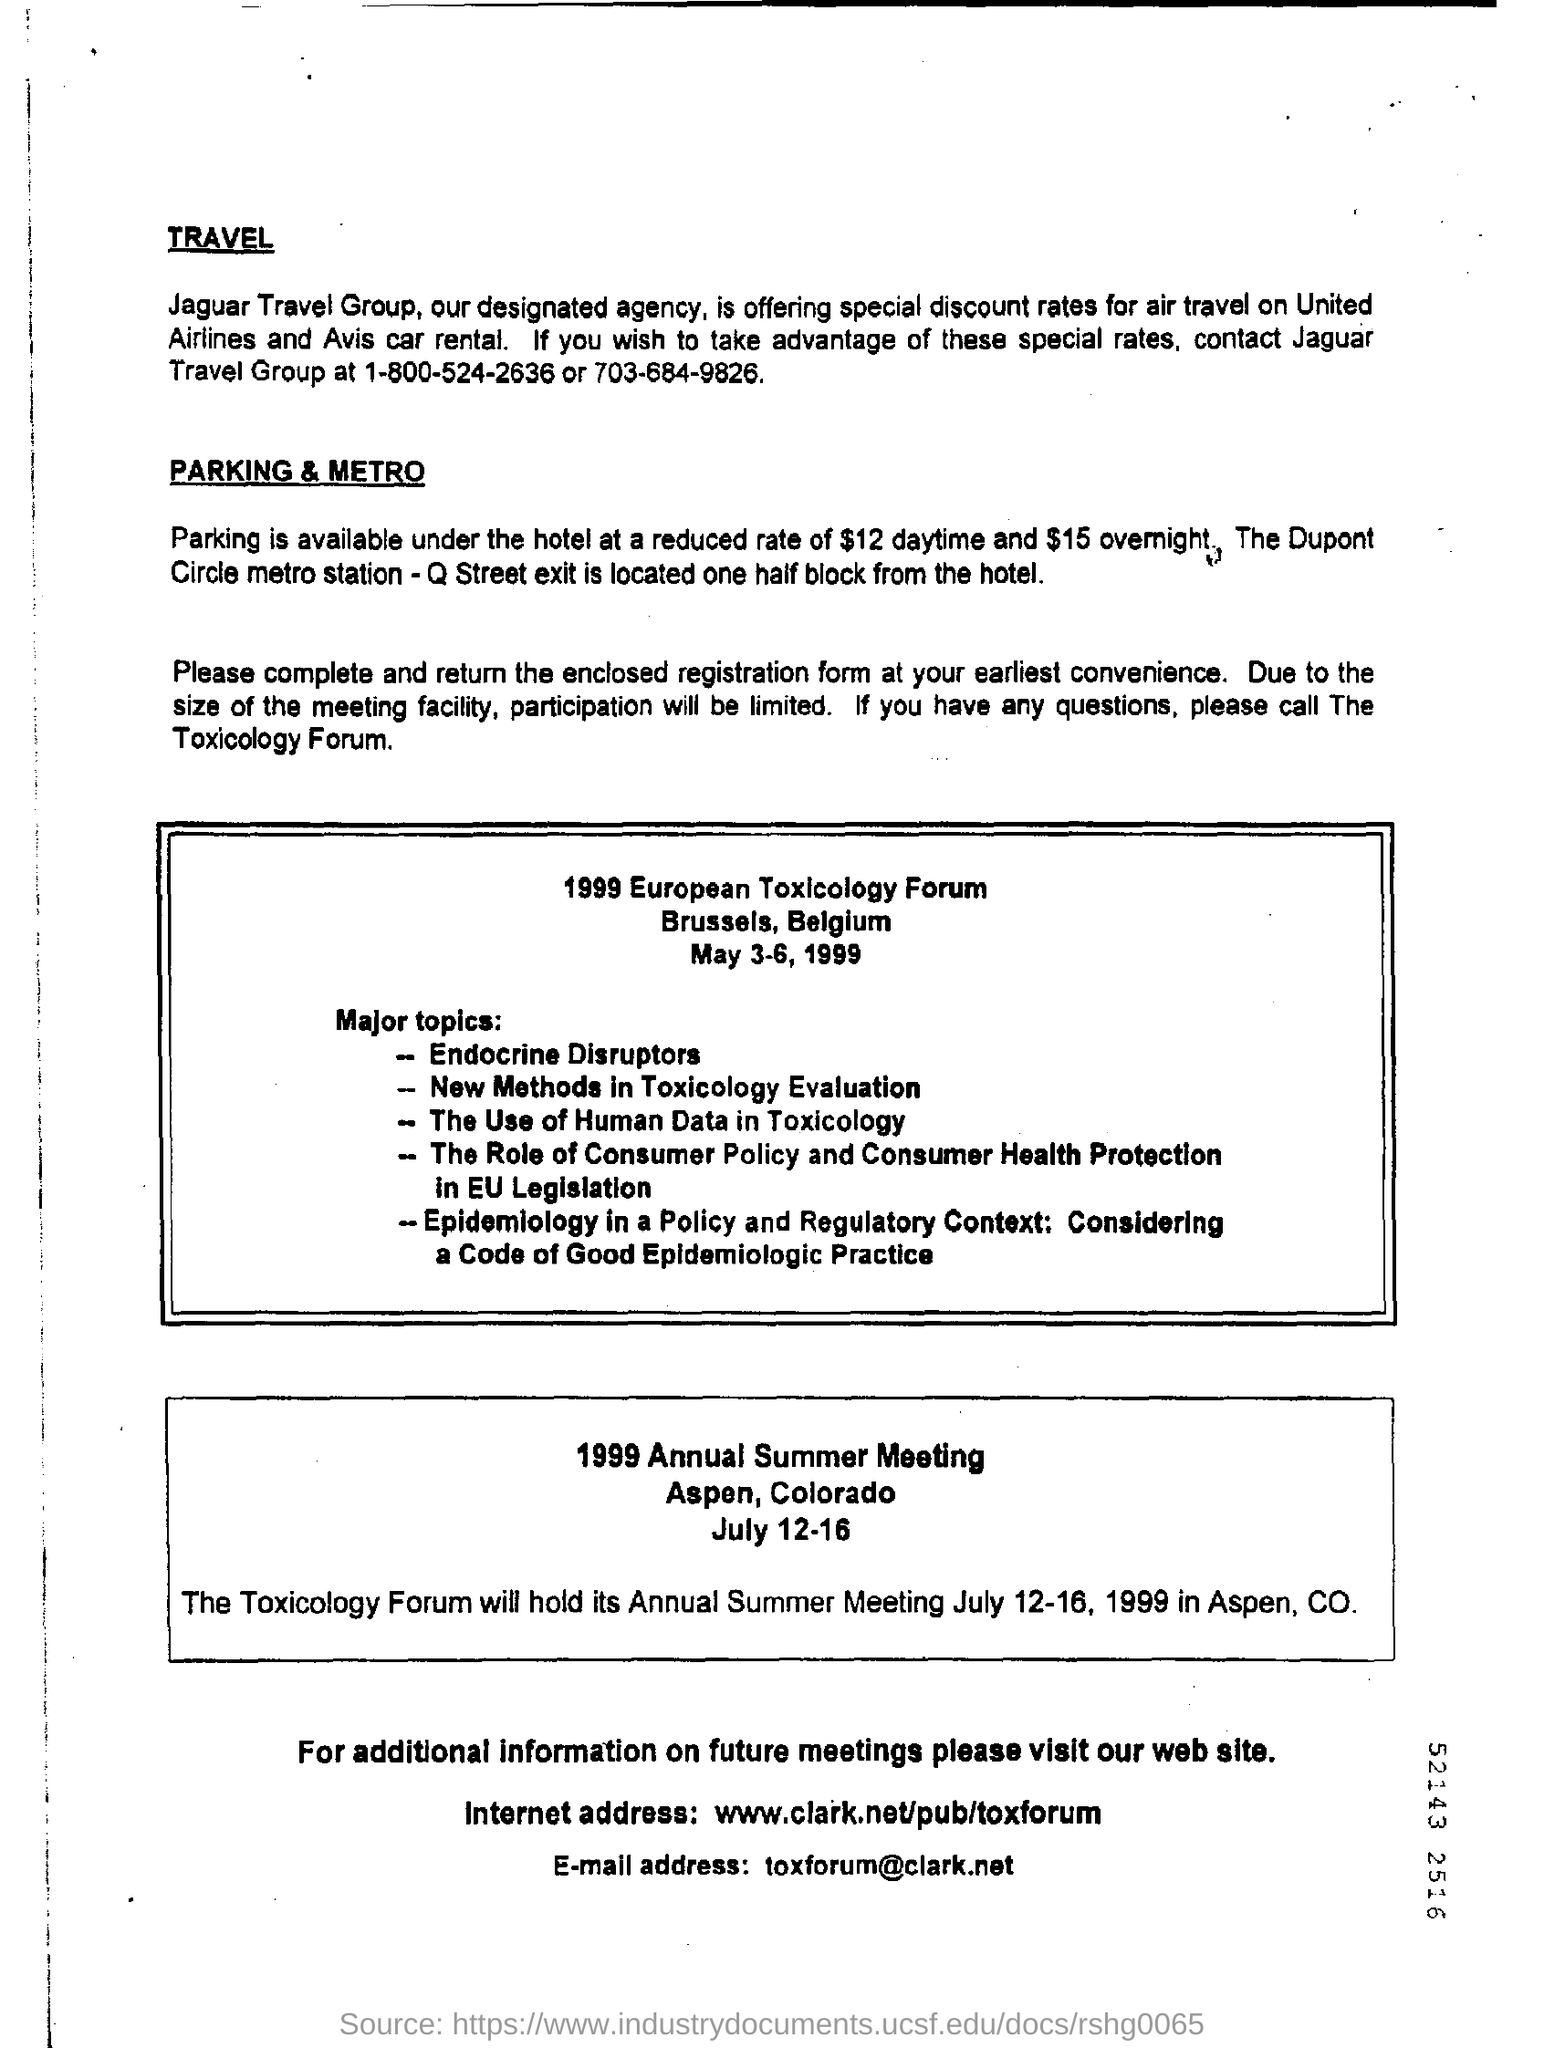What is the name of the travel group ?
Ensure brevity in your answer.  Jaguar. What is the contact number of jaguar travel group ?
Ensure brevity in your answer.  1-800-524-2636 or 703-684-9826. What is the cost of the parking at hotel in daytime ?
Make the answer very short. $12. What is the cost of the parking at the hotel overnight ?
Give a very brief answer. $15. What is the internet address given in the page ?
Provide a succinct answer. Www.clark.net/pub/toxforum. What is the e-mail address mentioned in the page ?
Your response must be concise. Toxforum@clark.net. 